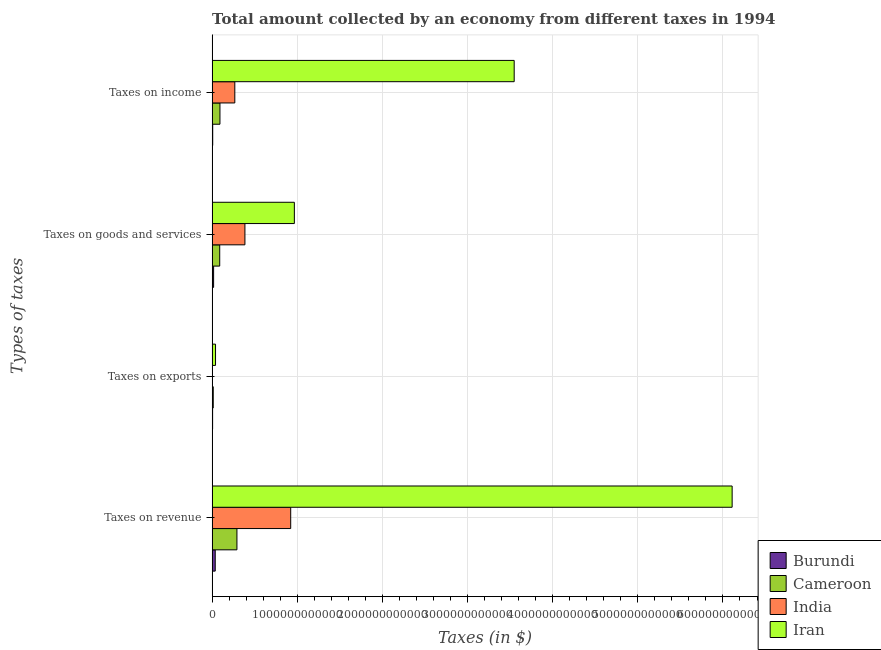How many different coloured bars are there?
Give a very brief answer. 4. Are the number of bars per tick equal to the number of legend labels?
Keep it short and to the point. Yes. How many bars are there on the 4th tick from the bottom?
Provide a succinct answer. 4. What is the label of the 2nd group of bars from the top?
Offer a terse response. Taxes on goods and services. What is the amount collected as tax on income in India?
Keep it short and to the point. 2.66e+11. Across all countries, what is the maximum amount collected as tax on revenue?
Your response must be concise. 6.11e+12. Across all countries, what is the minimum amount collected as tax on goods?
Your answer should be very brief. 1.76e+1. In which country was the amount collected as tax on revenue maximum?
Your answer should be very brief. Iran. In which country was the amount collected as tax on goods minimum?
Your answer should be very brief. Burundi. What is the total amount collected as tax on revenue in the graph?
Offer a terse response. 7.36e+12. What is the difference between the amount collected as tax on income in Burundi and that in Iran?
Your answer should be compact. -3.54e+12. What is the difference between the amount collected as tax on goods in Cameroon and the amount collected as tax on exports in Iran?
Ensure brevity in your answer.  4.93e+1. What is the average amount collected as tax on income per country?
Provide a succinct answer. 9.78e+11. What is the difference between the amount collected as tax on goods and amount collected as tax on revenue in Iran?
Provide a succinct answer. -5.14e+12. In how many countries, is the amount collected as tax on income greater than 2200000000000 $?
Your answer should be compact. 1. What is the ratio of the amount collected as tax on goods in Burundi to that in Iran?
Provide a succinct answer. 0.02. What is the difference between the highest and the second highest amount collected as tax on exports?
Provide a short and direct response. 2.68e+1. What is the difference between the highest and the lowest amount collected as tax on revenue?
Your answer should be compact. 6.07e+12. In how many countries, is the amount collected as tax on exports greater than the average amount collected as tax on exports taken over all countries?
Provide a succinct answer. 1. Is the sum of the amount collected as tax on goods in India and Cameroon greater than the maximum amount collected as tax on income across all countries?
Your answer should be very brief. No. Is it the case that in every country, the sum of the amount collected as tax on revenue and amount collected as tax on income is greater than the sum of amount collected as tax on exports and amount collected as tax on goods?
Give a very brief answer. Yes. What does the 1st bar from the top in Taxes on income represents?
Give a very brief answer. Iran. What does the 3rd bar from the bottom in Taxes on revenue represents?
Keep it short and to the point. India. Is it the case that in every country, the sum of the amount collected as tax on revenue and amount collected as tax on exports is greater than the amount collected as tax on goods?
Ensure brevity in your answer.  Yes. How many bars are there?
Give a very brief answer. 16. Are all the bars in the graph horizontal?
Keep it short and to the point. Yes. What is the difference between two consecutive major ticks on the X-axis?
Keep it short and to the point. 1.00e+12. Are the values on the major ticks of X-axis written in scientific E-notation?
Your answer should be very brief. No. Does the graph contain grids?
Your answer should be compact. Yes. Where does the legend appear in the graph?
Your answer should be compact. Bottom right. How many legend labels are there?
Ensure brevity in your answer.  4. What is the title of the graph?
Offer a very short reply. Total amount collected by an economy from different taxes in 1994. Does "East Asia (all income levels)" appear as one of the legend labels in the graph?
Offer a terse response. No. What is the label or title of the X-axis?
Provide a succinct answer. Taxes (in $). What is the label or title of the Y-axis?
Make the answer very short. Types of taxes. What is the Taxes (in $) in Burundi in Taxes on revenue?
Offer a terse response. 3.65e+1. What is the Taxes (in $) of Cameroon in Taxes on revenue?
Your answer should be very brief. 2.92e+11. What is the Taxes (in $) of India in Taxes on revenue?
Ensure brevity in your answer.  9.23e+11. What is the Taxes (in $) in Iran in Taxes on revenue?
Your answer should be very brief. 6.11e+12. What is the Taxes (in $) of Burundi in Taxes on exports?
Provide a short and direct response. 5.65e+09. What is the Taxes (in $) of Cameroon in Taxes on exports?
Offer a terse response. 1.32e+1. What is the Taxes (in $) of India in Taxes on exports?
Offer a terse response. 1.41e+09. What is the Taxes (in $) in Iran in Taxes on exports?
Your answer should be very brief. 4.00e+1. What is the Taxes (in $) of Burundi in Taxes on goods and services?
Provide a short and direct response. 1.76e+1. What is the Taxes (in $) in Cameroon in Taxes on goods and services?
Provide a succinct answer. 8.93e+1. What is the Taxes (in $) in India in Taxes on goods and services?
Keep it short and to the point. 3.85e+11. What is the Taxes (in $) of Iran in Taxes on goods and services?
Offer a very short reply. 9.66e+11. What is the Taxes (in $) of Burundi in Taxes on income?
Keep it short and to the point. 7.01e+09. What is the Taxes (in $) of Cameroon in Taxes on income?
Keep it short and to the point. 9.19e+1. What is the Taxes (in $) in India in Taxes on income?
Provide a short and direct response. 2.66e+11. What is the Taxes (in $) of Iran in Taxes on income?
Provide a succinct answer. 3.55e+12. Across all Types of taxes, what is the maximum Taxes (in $) in Burundi?
Provide a short and direct response. 3.65e+1. Across all Types of taxes, what is the maximum Taxes (in $) of Cameroon?
Your answer should be compact. 2.92e+11. Across all Types of taxes, what is the maximum Taxes (in $) of India?
Your answer should be very brief. 9.23e+11. Across all Types of taxes, what is the maximum Taxes (in $) of Iran?
Your answer should be compact. 6.11e+12. Across all Types of taxes, what is the minimum Taxes (in $) of Burundi?
Offer a terse response. 5.65e+09. Across all Types of taxes, what is the minimum Taxes (in $) of Cameroon?
Your response must be concise. 1.32e+1. Across all Types of taxes, what is the minimum Taxes (in $) in India?
Your answer should be very brief. 1.41e+09. Across all Types of taxes, what is the minimum Taxes (in $) of Iran?
Ensure brevity in your answer.  4.00e+1. What is the total Taxes (in $) in Burundi in the graph?
Your response must be concise. 6.67e+1. What is the total Taxes (in $) in Cameroon in the graph?
Give a very brief answer. 4.86e+11. What is the total Taxes (in $) of India in the graph?
Ensure brevity in your answer.  1.58e+12. What is the total Taxes (in $) of Iran in the graph?
Provide a succinct answer. 1.07e+13. What is the difference between the Taxes (in $) in Burundi in Taxes on revenue and that in Taxes on exports?
Offer a terse response. 3.08e+1. What is the difference between the Taxes (in $) of Cameroon in Taxes on revenue and that in Taxes on exports?
Make the answer very short. 2.78e+11. What is the difference between the Taxes (in $) in India in Taxes on revenue and that in Taxes on exports?
Keep it short and to the point. 9.22e+11. What is the difference between the Taxes (in $) of Iran in Taxes on revenue and that in Taxes on exports?
Keep it short and to the point. 6.07e+12. What is the difference between the Taxes (in $) of Burundi in Taxes on revenue and that in Taxes on goods and services?
Offer a terse response. 1.89e+1. What is the difference between the Taxes (in $) in Cameroon in Taxes on revenue and that in Taxes on goods and services?
Provide a short and direct response. 2.02e+11. What is the difference between the Taxes (in $) in India in Taxes on revenue and that in Taxes on goods and services?
Your answer should be very brief. 5.38e+11. What is the difference between the Taxes (in $) of Iran in Taxes on revenue and that in Taxes on goods and services?
Your response must be concise. 5.14e+12. What is the difference between the Taxes (in $) of Burundi in Taxes on revenue and that in Taxes on income?
Keep it short and to the point. 2.95e+1. What is the difference between the Taxes (in $) of Cameroon in Taxes on revenue and that in Taxes on income?
Give a very brief answer. 2.00e+11. What is the difference between the Taxes (in $) of India in Taxes on revenue and that in Taxes on income?
Your answer should be very brief. 6.56e+11. What is the difference between the Taxes (in $) of Iran in Taxes on revenue and that in Taxes on income?
Ensure brevity in your answer.  2.56e+12. What is the difference between the Taxes (in $) of Burundi in Taxes on exports and that in Taxes on goods and services?
Offer a very short reply. -1.19e+1. What is the difference between the Taxes (in $) in Cameroon in Taxes on exports and that in Taxes on goods and services?
Give a very brief answer. -7.61e+1. What is the difference between the Taxes (in $) of India in Taxes on exports and that in Taxes on goods and services?
Give a very brief answer. -3.84e+11. What is the difference between the Taxes (in $) in Iran in Taxes on exports and that in Taxes on goods and services?
Provide a short and direct response. -9.26e+11. What is the difference between the Taxes (in $) of Burundi in Taxes on exports and that in Taxes on income?
Offer a very short reply. -1.36e+09. What is the difference between the Taxes (in $) in Cameroon in Taxes on exports and that in Taxes on income?
Offer a terse response. -7.87e+1. What is the difference between the Taxes (in $) of India in Taxes on exports and that in Taxes on income?
Offer a very short reply. -2.65e+11. What is the difference between the Taxes (in $) of Iran in Taxes on exports and that in Taxes on income?
Give a very brief answer. -3.51e+12. What is the difference between the Taxes (in $) of Burundi in Taxes on goods and services and that in Taxes on income?
Offer a very short reply. 1.05e+1. What is the difference between the Taxes (in $) of Cameroon in Taxes on goods and services and that in Taxes on income?
Provide a short and direct response. -2.63e+09. What is the difference between the Taxes (in $) in India in Taxes on goods and services and that in Taxes on income?
Your response must be concise. 1.19e+11. What is the difference between the Taxes (in $) in Iran in Taxes on goods and services and that in Taxes on income?
Provide a succinct answer. -2.58e+12. What is the difference between the Taxes (in $) in Burundi in Taxes on revenue and the Taxes (in $) in Cameroon in Taxes on exports?
Your response must be concise. 2.33e+1. What is the difference between the Taxes (in $) in Burundi in Taxes on revenue and the Taxes (in $) in India in Taxes on exports?
Ensure brevity in your answer.  3.51e+1. What is the difference between the Taxes (in $) of Burundi in Taxes on revenue and the Taxes (in $) of Iran in Taxes on exports?
Your answer should be very brief. -3.50e+09. What is the difference between the Taxes (in $) of Cameroon in Taxes on revenue and the Taxes (in $) of India in Taxes on exports?
Make the answer very short. 2.90e+11. What is the difference between the Taxes (in $) in Cameroon in Taxes on revenue and the Taxes (in $) in Iran in Taxes on exports?
Ensure brevity in your answer.  2.52e+11. What is the difference between the Taxes (in $) of India in Taxes on revenue and the Taxes (in $) of Iran in Taxes on exports?
Offer a terse response. 8.83e+11. What is the difference between the Taxes (in $) in Burundi in Taxes on revenue and the Taxes (in $) in Cameroon in Taxes on goods and services?
Give a very brief answer. -5.28e+1. What is the difference between the Taxes (in $) in Burundi in Taxes on revenue and the Taxes (in $) in India in Taxes on goods and services?
Offer a terse response. -3.49e+11. What is the difference between the Taxes (in $) of Burundi in Taxes on revenue and the Taxes (in $) of Iran in Taxes on goods and services?
Ensure brevity in your answer.  -9.30e+11. What is the difference between the Taxes (in $) in Cameroon in Taxes on revenue and the Taxes (in $) in India in Taxes on goods and services?
Offer a very short reply. -9.37e+1. What is the difference between the Taxes (in $) of Cameroon in Taxes on revenue and the Taxes (in $) of Iran in Taxes on goods and services?
Offer a very short reply. -6.74e+11. What is the difference between the Taxes (in $) of India in Taxes on revenue and the Taxes (in $) of Iran in Taxes on goods and services?
Offer a very short reply. -4.31e+1. What is the difference between the Taxes (in $) of Burundi in Taxes on revenue and the Taxes (in $) of Cameroon in Taxes on income?
Ensure brevity in your answer.  -5.54e+1. What is the difference between the Taxes (in $) of Burundi in Taxes on revenue and the Taxes (in $) of India in Taxes on income?
Your answer should be very brief. -2.30e+11. What is the difference between the Taxes (in $) in Burundi in Taxes on revenue and the Taxes (in $) in Iran in Taxes on income?
Your response must be concise. -3.51e+12. What is the difference between the Taxes (in $) in Cameroon in Taxes on revenue and the Taxes (in $) in India in Taxes on income?
Make the answer very short. 2.51e+1. What is the difference between the Taxes (in $) in Cameroon in Taxes on revenue and the Taxes (in $) in Iran in Taxes on income?
Give a very brief answer. -3.26e+12. What is the difference between the Taxes (in $) of India in Taxes on revenue and the Taxes (in $) of Iran in Taxes on income?
Provide a short and direct response. -2.63e+12. What is the difference between the Taxes (in $) in Burundi in Taxes on exports and the Taxes (in $) in Cameroon in Taxes on goods and services?
Provide a short and direct response. -8.37e+1. What is the difference between the Taxes (in $) in Burundi in Taxes on exports and the Taxes (in $) in India in Taxes on goods and services?
Make the answer very short. -3.80e+11. What is the difference between the Taxes (in $) of Burundi in Taxes on exports and the Taxes (in $) of Iran in Taxes on goods and services?
Offer a terse response. -9.60e+11. What is the difference between the Taxes (in $) of Cameroon in Taxes on exports and the Taxes (in $) of India in Taxes on goods and services?
Provide a succinct answer. -3.72e+11. What is the difference between the Taxes (in $) in Cameroon in Taxes on exports and the Taxes (in $) in Iran in Taxes on goods and services?
Offer a very short reply. -9.53e+11. What is the difference between the Taxes (in $) in India in Taxes on exports and the Taxes (in $) in Iran in Taxes on goods and services?
Offer a terse response. -9.65e+11. What is the difference between the Taxes (in $) in Burundi in Taxes on exports and the Taxes (in $) in Cameroon in Taxes on income?
Offer a very short reply. -8.63e+1. What is the difference between the Taxes (in $) of Burundi in Taxes on exports and the Taxes (in $) of India in Taxes on income?
Provide a short and direct response. -2.61e+11. What is the difference between the Taxes (in $) of Burundi in Taxes on exports and the Taxes (in $) of Iran in Taxes on income?
Ensure brevity in your answer.  -3.54e+12. What is the difference between the Taxes (in $) of Cameroon in Taxes on exports and the Taxes (in $) of India in Taxes on income?
Your response must be concise. -2.53e+11. What is the difference between the Taxes (in $) in Cameroon in Taxes on exports and the Taxes (in $) in Iran in Taxes on income?
Make the answer very short. -3.53e+12. What is the difference between the Taxes (in $) of India in Taxes on exports and the Taxes (in $) of Iran in Taxes on income?
Provide a succinct answer. -3.55e+12. What is the difference between the Taxes (in $) in Burundi in Taxes on goods and services and the Taxes (in $) in Cameroon in Taxes on income?
Your answer should be very brief. -7.44e+1. What is the difference between the Taxes (in $) of Burundi in Taxes on goods and services and the Taxes (in $) of India in Taxes on income?
Your answer should be very brief. -2.49e+11. What is the difference between the Taxes (in $) in Burundi in Taxes on goods and services and the Taxes (in $) in Iran in Taxes on income?
Provide a succinct answer. -3.53e+12. What is the difference between the Taxes (in $) of Cameroon in Taxes on goods and services and the Taxes (in $) of India in Taxes on income?
Make the answer very short. -1.77e+11. What is the difference between the Taxes (in $) in Cameroon in Taxes on goods and services and the Taxes (in $) in Iran in Taxes on income?
Provide a succinct answer. -3.46e+12. What is the difference between the Taxes (in $) of India in Taxes on goods and services and the Taxes (in $) of Iran in Taxes on income?
Make the answer very short. -3.16e+12. What is the average Taxes (in $) of Burundi per Types of taxes?
Offer a very short reply. 1.67e+1. What is the average Taxes (in $) in Cameroon per Types of taxes?
Provide a short and direct response. 1.22e+11. What is the average Taxes (in $) in India per Types of taxes?
Give a very brief answer. 3.94e+11. What is the average Taxes (in $) of Iran per Types of taxes?
Keep it short and to the point. 2.67e+12. What is the difference between the Taxes (in $) of Burundi and Taxes (in $) of Cameroon in Taxes on revenue?
Keep it short and to the point. -2.55e+11. What is the difference between the Taxes (in $) in Burundi and Taxes (in $) in India in Taxes on revenue?
Your answer should be compact. -8.86e+11. What is the difference between the Taxes (in $) of Burundi and Taxes (in $) of Iran in Taxes on revenue?
Give a very brief answer. -6.07e+12. What is the difference between the Taxes (in $) of Cameroon and Taxes (in $) of India in Taxes on revenue?
Give a very brief answer. -6.31e+11. What is the difference between the Taxes (in $) of Cameroon and Taxes (in $) of Iran in Taxes on revenue?
Make the answer very short. -5.82e+12. What is the difference between the Taxes (in $) of India and Taxes (in $) of Iran in Taxes on revenue?
Provide a succinct answer. -5.19e+12. What is the difference between the Taxes (in $) in Burundi and Taxes (in $) in Cameroon in Taxes on exports?
Ensure brevity in your answer.  -7.58e+09. What is the difference between the Taxes (in $) of Burundi and Taxes (in $) of India in Taxes on exports?
Ensure brevity in your answer.  4.24e+09. What is the difference between the Taxes (in $) of Burundi and Taxes (in $) of Iran in Taxes on exports?
Give a very brief answer. -3.43e+1. What is the difference between the Taxes (in $) of Cameroon and Taxes (in $) of India in Taxes on exports?
Offer a terse response. 1.18e+1. What is the difference between the Taxes (in $) in Cameroon and Taxes (in $) in Iran in Taxes on exports?
Keep it short and to the point. -2.68e+1. What is the difference between the Taxes (in $) in India and Taxes (in $) in Iran in Taxes on exports?
Your answer should be very brief. -3.86e+1. What is the difference between the Taxes (in $) of Burundi and Taxes (in $) of Cameroon in Taxes on goods and services?
Ensure brevity in your answer.  -7.18e+1. What is the difference between the Taxes (in $) in Burundi and Taxes (in $) in India in Taxes on goods and services?
Your response must be concise. -3.68e+11. What is the difference between the Taxes (in $) in Burundi and Taxes (in $) in Iran in Taxes on goods and services?
Your answer should be compact. -9.48e+11. What is the difference between the Taxes (in $) of Cameroon and Taxes (in $) of India in Taxes on goods and services?
Your answer should be compact. -2.96e+11. What is the difference between the Taxes (in $) of Cameroon and Taxes (in $) of Iran in Taxes on goods and services?
Your response must be concise. -8.77e+11. What is the difference between the Taxes (in $) in India and Taxes (in $) in Iran in Taxes on goods and services?
Offer a very short reply. -5.81e+11. What is the difference between the Taxes (in $) of Burundi and Taxes (in $) of Cameroon in Taxes on income?
Your answer should be compact. -8.49e+1. What is the difference between the Taxes (in $) of Burundi and Taxes (in $) of India in Taxes on income?
Ensure brevity in your answer.  -2.59e+11. What is the difference between the Taxes (in $) in Burundi and Taxes (in $) in Iran in Taxes on income?
Provide a short and direct response. -3.54e+12. What is the difference between the Taxes (in $) in Cameroon and Taxes (in $) in India in Taxes on income?
Offer a very short reply. -1.75e+11. What is the difference between the Taxes (in $) in Cameroon and Taxes (in $) in Iran in Taxes on income?
Your answer should be very brief. -3.46e+12. What is the difference between the Taxes (in $) in India and Taxes (in $) in Iran in Taxes on income?
Give a very brief answer. -3.28e+12. What is the ratio of the Taxes (in $) of Burundi in Taxes on revenue to that in Taxes on exports?
Provide a short and direct response. 6.46. What is the ratio of the Taxes (in $) in Cameroon in Taxes on revenue to that in Taxes on exports?
Provide a succinct answer. 22.04. What is the ratio of the Taxes (in $) in India in Taxes on revenue to that in Taxes on exports?
Make the answer very short. 654.57. What is the ratio of the Taxes (in $) in Iran in Taxes on revenue to that in Taxes on exports?
Provide a succinct answer. 152.7. What is the ratio of the Taxes (in $) in Burundi in Taxes on revenue to that in Taxes on goods and services?
Provide a short and direct response. 2.08. What is the ratio of the Taxes (in $) in Cameroon in Taxes on revenue to that in Taxes on goods and services?
Offer a very short reply. 3.26. What is the ratio of the Taxes (in $) in India in Taxes on revenue to that in Taxes on goods and services?
Provide a short and direct response. 2.4. What is the ratio of the Taxes (in $) of Iran in Taxes on revenue to that in Taxes on goods and services?
Provide a short and direct response. 6.32. What is the ratio of the Taxes (in $) in Burundi in Taxes on revenue to that in Taxes on income?
Your answer should be compact. 5.21. What is the ratio of the Taxes (in $) of Cameroon in Taxes on revenue to that in Taxes on income?
Ensure brevity in your answer.  3.17. What is the ratio of the Taxes (in $) in India in Taxes on revenue to that in Taxes on income?
Offer a very short reply. 3.46. What is the ratio of the Taxes (in $) in Iran in Taxes on revenue to that in Taxes on income?
Keep it short and to the point. 1.72. What is the ratio of the Taxes (in $) of Burundi in Taxes on exports to that in Taxes on goods and services?
Your answer should be very brief. 0.32. What is the ratio of the Taxes (in $) in Cameroon in Taxes on exports to that in Taxes on goods and services?
Your answer should be very brief. 0.15. What is the ratio of the Taxes (in $) in India in Taxes on exports to that in Taxes on goods and services?
Offer a terse response. 0. What is the ratio of the Taxes (in $) in Iran in Taxes on exports to that in Taxes on goods and services?
Offer a very short reply. 0.04. What is the ratio of the Taxes (in $) in Burundi in Taxes on exports to that in Taxes on income?
Make the answer very short. 0.81. What is the ratio of the Taxes (in $) of Cameroon in Taxes on exports to that in Taxes on income?
Give a very brief answer. 0.14. What is the ratio of the Taxes (in $) of India in Taxes on exports to that in Taxes on income?
Offer a terse response. 0.01. What is the ratio of the Taxes (in $) in Iran in Taxes on exports to that in Taxes on income?
Give a very brief answer. 0.01. What is the ratio of the Taxes (in $) of Burundi in Taxes on goods and services to that in Taxes on income?
Offer a terse response. 2.5. What is the ratio of the Taxes (in $) of Cameroon in Taxes on goods and services to that in Taxes on income?
Keep it short and to the point. 0.97. What is the ratio of the Taxes (in $) of India in Taxes on goods and services to that in Taxes on income?
Ensure brevity in your answer.  1.45. What is the ratio of the Taxes (in $) in Iran in Taxes on goods and services to that in Taxes on income?
Give a very brief answer. 0.27. What is the difference between the highest and the second highest Taxes (in $) of Burundi?
Ensure brevity in your answer.  1.89e+1. What is the difference between the highest and the second highest Taxes (in $) of Cameroon?
Provide a short and direct response. 2.00e+11. What is the difference between the highest and the second highest Taxes (in $) in India?
Your answer should be very brief. 5.38e+11. What is the difference between the highest and the second highest Taxes (in $) of Iran?
Your answer should be very brief. 2.56e+12. What is the difference between the highest and the lowest Taxes (in $) in Burundi?
Your response must be concise. 3.08e+1. What is the difference between the highest and the lowest Taxes (in $) of Cameroon?
Offer a very short reply. 2.78e+11. What is the difference between the highest and the lowest Taxes (in $) of India?
Your answer should be compact. 9.22e+11. What is the difference between the highest and the lowest Taxes (in $) of Iran?
Your response must be concise. 6.07e+12. 